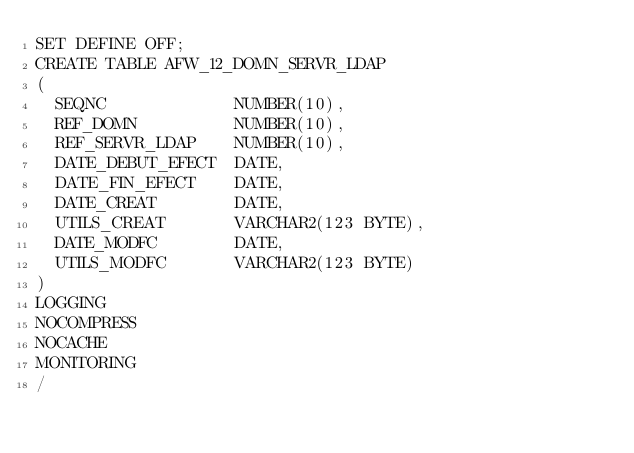Convert code to text. <code><loc_0><loc_0><loc_500><loc_500><_SQL_>SET DEFINE OFF;
CREATE TABLE AFW_12_DOMN_SERVR_LDAP
(
  SEQNC             NUMBER(10),
  REF_DOMN          NUMBER(10),
  REF_SERVR_LDAP    NUMBER(10),
  DATE_DEBUT_EFECT  DATE,
  DATE_FIN_EFECT    DATE,
  DATE_CREAT        DATE,
  UTILS_CREAT       VARCHAR2(123 BYTE),
  DATE_MODFC        DATE,
  UTILS_MODFC       VARCHAR2(123 BYTE)
)
LOGGING 
NOCOMPRESS 
NOCACHE
MONITORING
/
</code> 